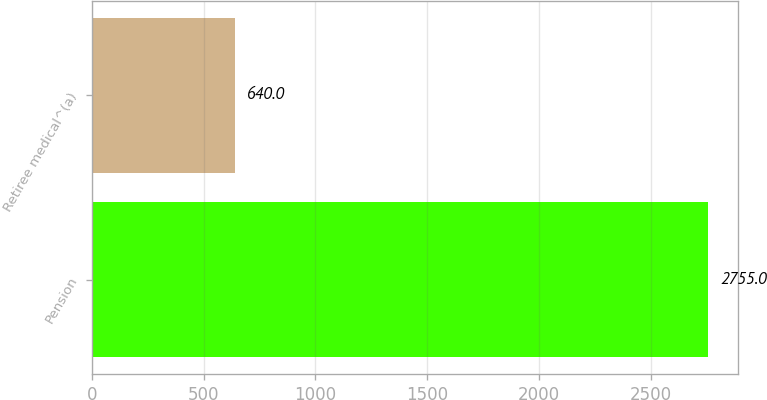Convert chart. <chart><loc_0><loc_0><loc_500><loc_500><bar_chart><fcel>Pension<fcel>Retiree medical^(a)<nl><fcel>2755<fcel>640<nl></chart> 